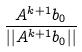Convert formula to latex. <formula><loc_0><loc_0><loc_500><loc_500>\frac { A ^ { k + 1 } b _ { 0 } } { | | A ^ { k + 1 } b _ { 0 } | | }</formula> 